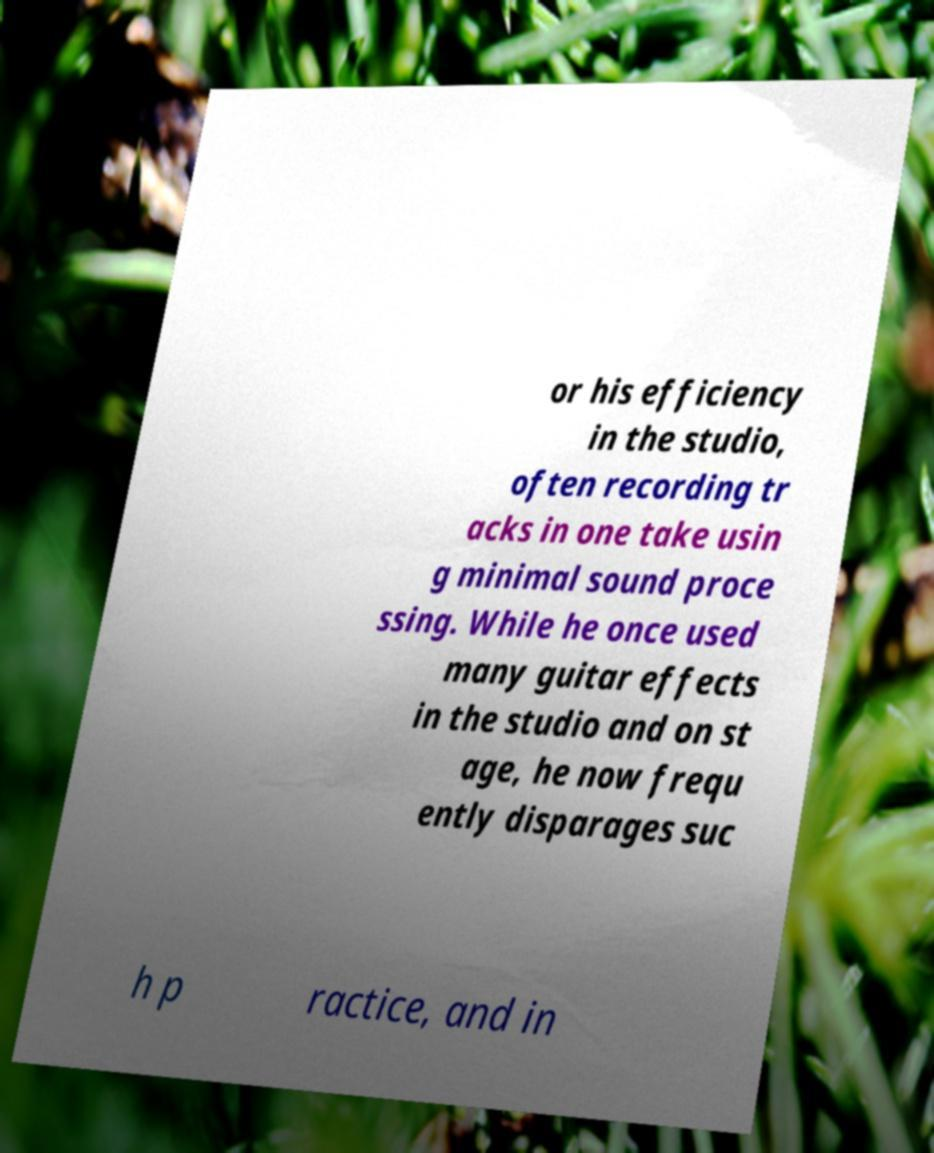Please read and relay the text visible in this image. What does it say? or his efficiency in the studio, often recording tr acks in one take usin g minimal sound proce ssing. While he once used many guitar effects in the studio and on st age, he now frequ ently disparages suc h p ractice, and in 